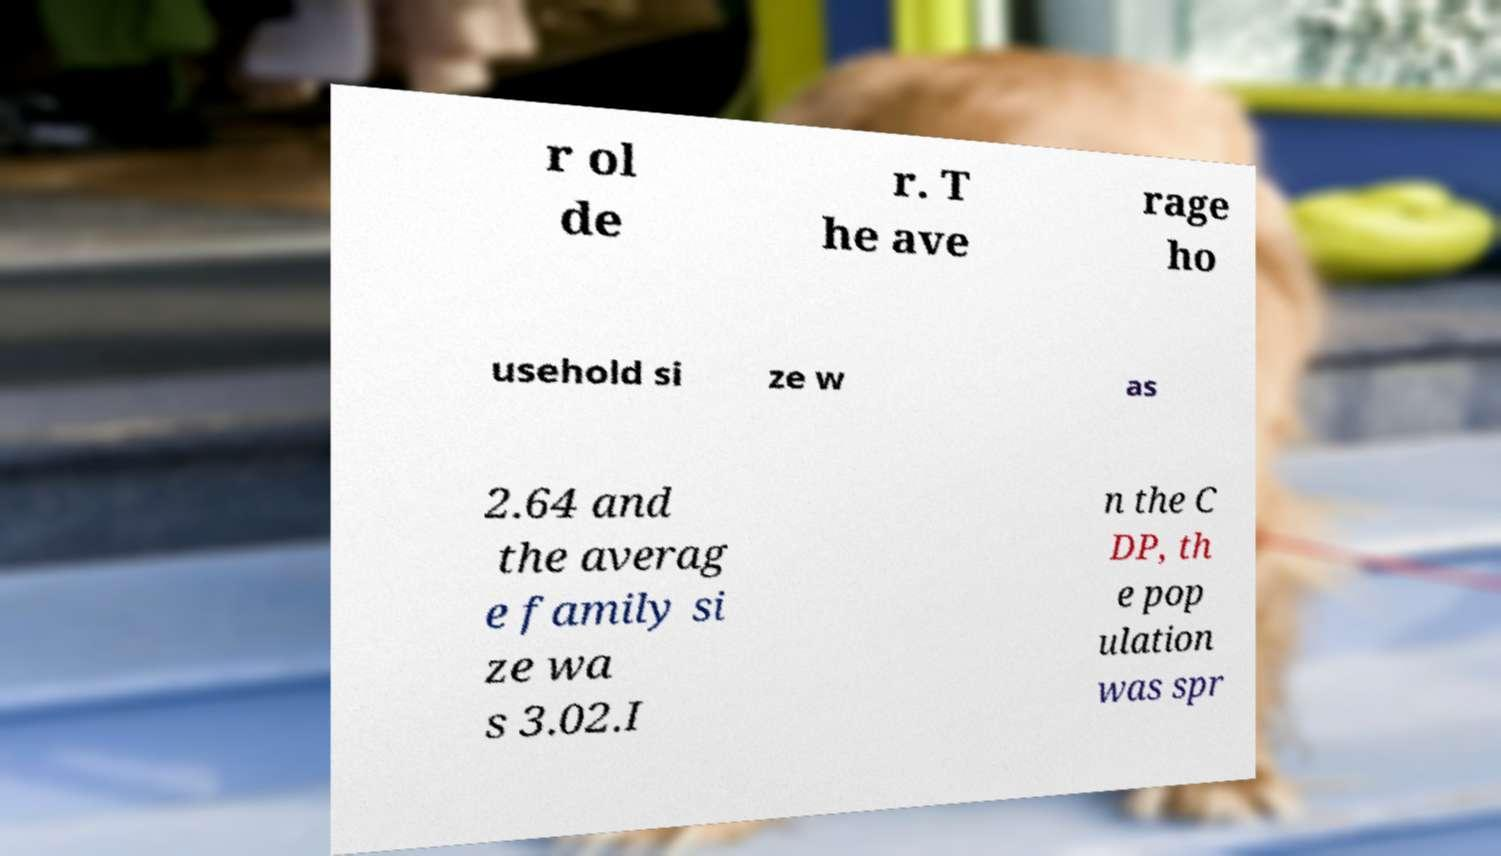There's text embedded in this image that I need extracted. Can you transcribe it verbatim? r ol de r. T he ave rage ho usehold si ze w as 2.64 and the averag e family si ze wa s 3.02.I n the C DP, th e pop ulation was spr 